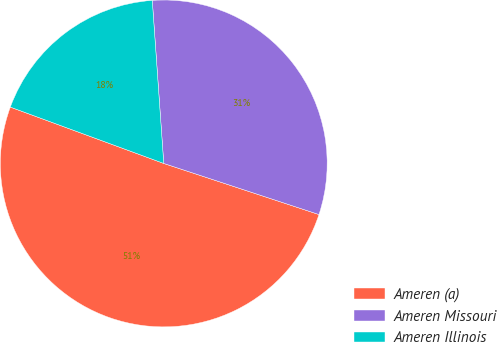Convert chart to OTSL. <chart><loc_0><loc_0><loc_500><loc_500><pie_chart><fcel>Ameren (a)<fcel>Ameren Missouri<fcel>Ameren Illinois<nl><fcel>50.54%<fcel>31.18%<fcel>18.28%<nl></chart> 